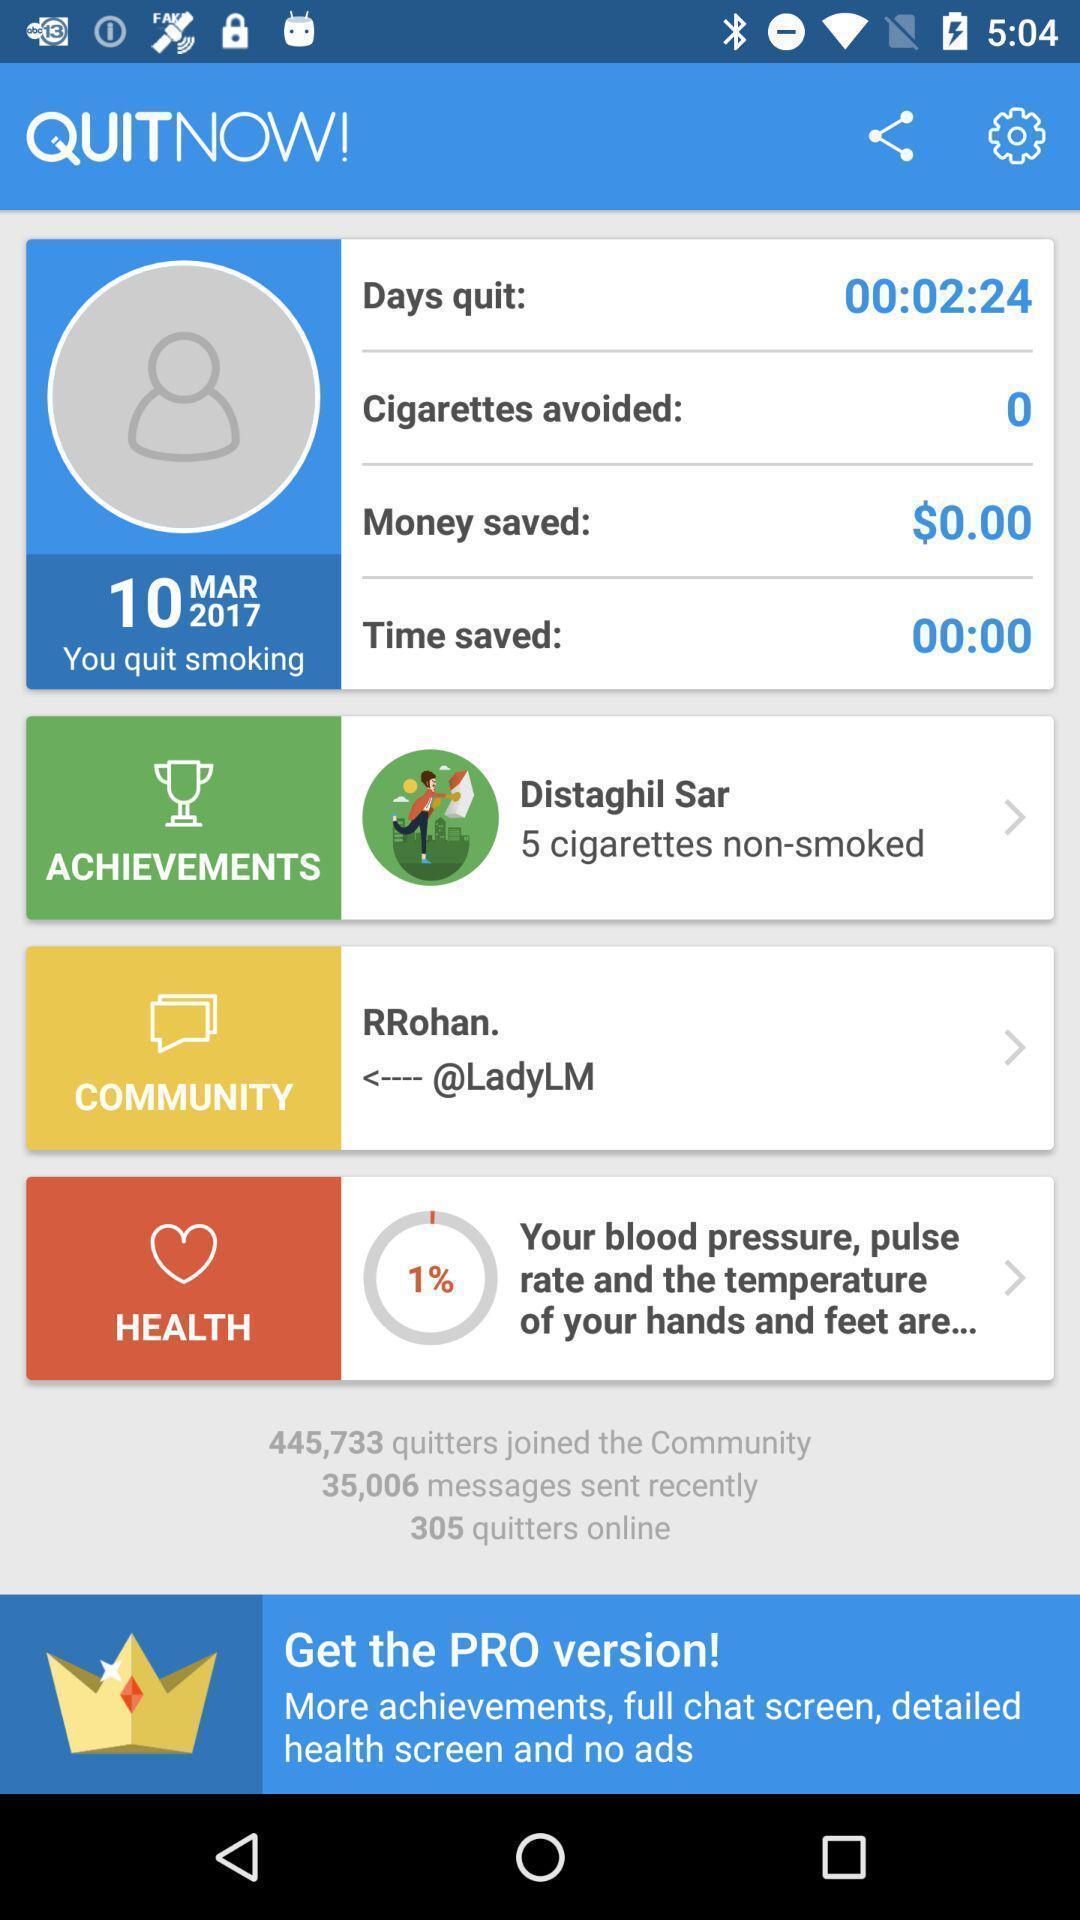Describe the visual elements of this screenshot. Screen page of a smoking quit app. 